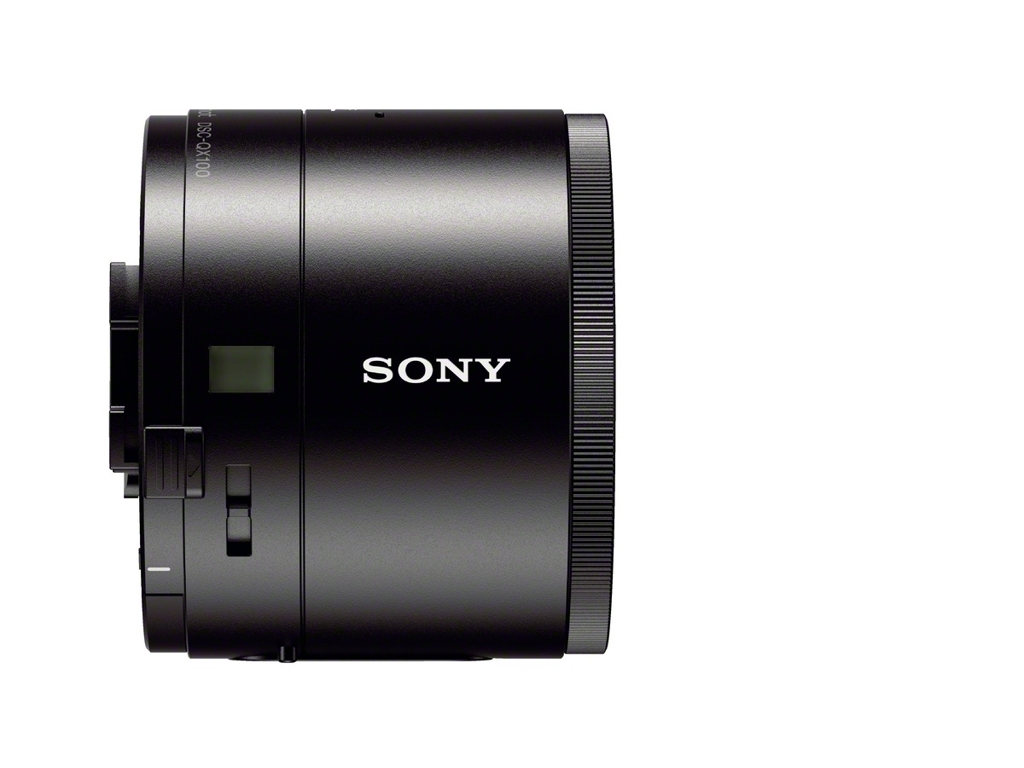Is this suitable for professional photography? SONY is known for producing professional-grade equipment. Although I can't confirm the exact model from the image, it is likely that this lens is suitable for various levels of photography, including professional use. 